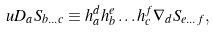Convert formula to latex. <formula><loc_0><loc_0><loc_500><loc_500>\ u D _ { a } S _ { b \dots c } \equiv h _ { a } ^ { d } h _ { b } ^ { e } \dots h _ { c } ^ { f } \nabla _ { d } S _ { e \dots f } ,</formula> 